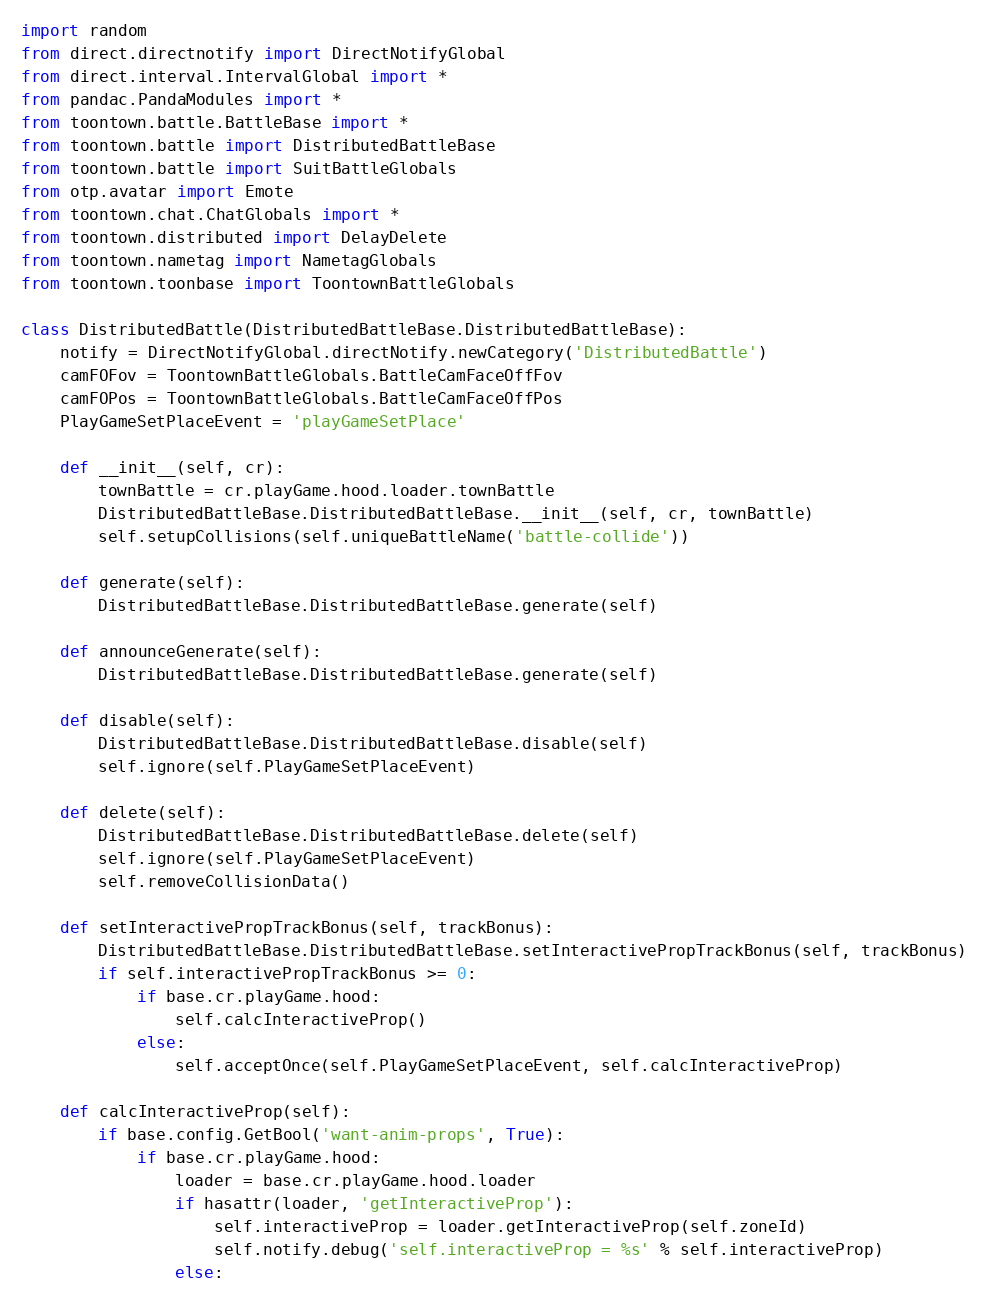<code> <loc_0><loc_0><loc_500><loc_500><_Python_>import random
from direct.directnotify import DirectNotifyGlobal
from direct.interval.IntervalGlobal import *
from pandac.PandaModules import *
from toontown.battle.BattleBase import *
from toontown.battle import DistributedBattleBase
from toontown.battle import SuitBattleGlobals
from otp.avatar import Emote
from toontown.chat.ChatGlobals import *
from toontown.distributed import DelayDelete
from toontown.nametag import NametagGlobals
from toontown.toonbase import ToontownBattleGlobals

class DistributedBattle(DistributedBattleBase.DistributedBattleBase):
    notify = DirectNotifyGlobal.directNotify.newCategory('DistributedBattle')
    camFOFov = ToontownBattleGlobals.BattleCamFaceOffFov
    camFOPos = ToontownBattleGlobals.BattleCamFaceOffPos
    PlayGameSetPlaceEvent = 'playGameSetPlace'

    def __init__(self, cr):
        townBattle = cr.playGame.hood.loader.townBattle
        DistributedBattleBase.DistributedBattleBase.__init__(self, cr, townBattle)
        self.setupCollisions(self.uniqueBattleName('battle-collide'))

    def generate(self):
        DistributedBattleBase.DistributedBattleBase.generate(self)

    def announceGenerate(self):
        DistributedBattleBase.DistributedBattleBase.generate(self)

    def disable(self):
        DistributedBattleBase.DistributedBattleBase.disable(self)
        self.ignore(self.PlayGameSetPlaceEvent)

    def delete(self):
        DistributedBattleBase.DistributedBattleBase.delete(self)
        self.ignore(self.PlayGameSetPlaceEvent)
        self.removeCollisionData()

    def setInteractivePropTrackBonus(self, trackBonus):
        DistributedBattleBase.DistributedBattleBase.setInteractivePropTrackBonus(self, trackBonus)
        if self.interactivePropTrackBonus >= 0:
            if base.cr.playGame.hood:
                self.calcInteractiveProp()
            else:
                self.acceptOnce(self.PlayGameSetPlaceEvent, self.calcInteractiveProp)

    def calcInteractiveProp(self):
        if base.config.GetBool('want-anim-props', True):
            if base.cr.playGame.hood:
                loader = base.cr.playGame.hood.loader
                if hasattr(loader, 'getInteractiveProp'):
                    self.interactiveProp = loader.getInteractiveProp(self.zoneId)
                    self.notify.debug('self.interactiveProp = %s' % self.interactiveProp)
                else:</code> 